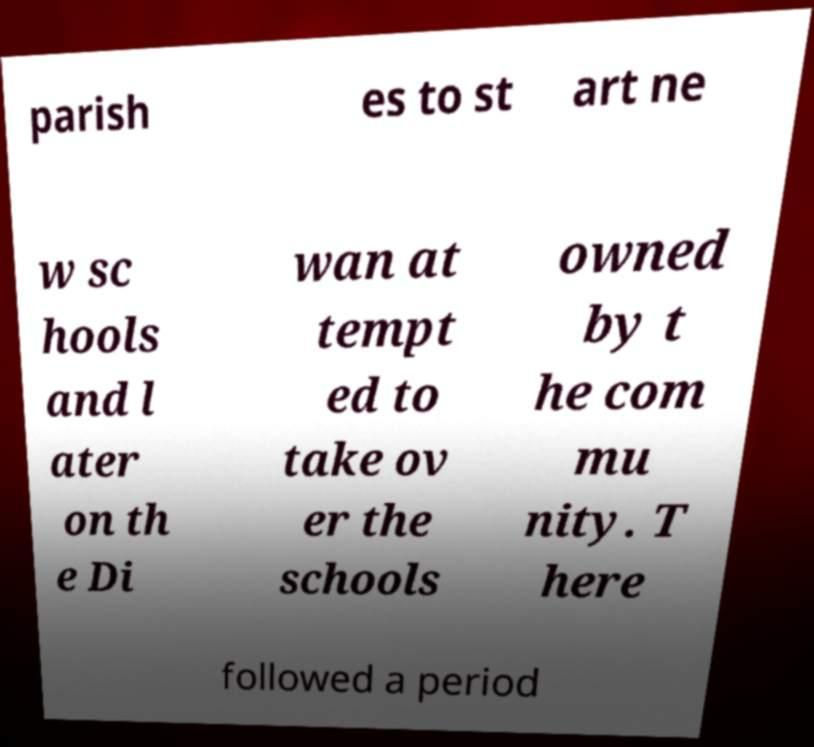Please read and relay the text visible in this image. What does it say? parish es to st art ne w sc hools and l ater on th e Di wan at tempt ed to take ov er the schools owned by t he com mu nity. T here followed a period 